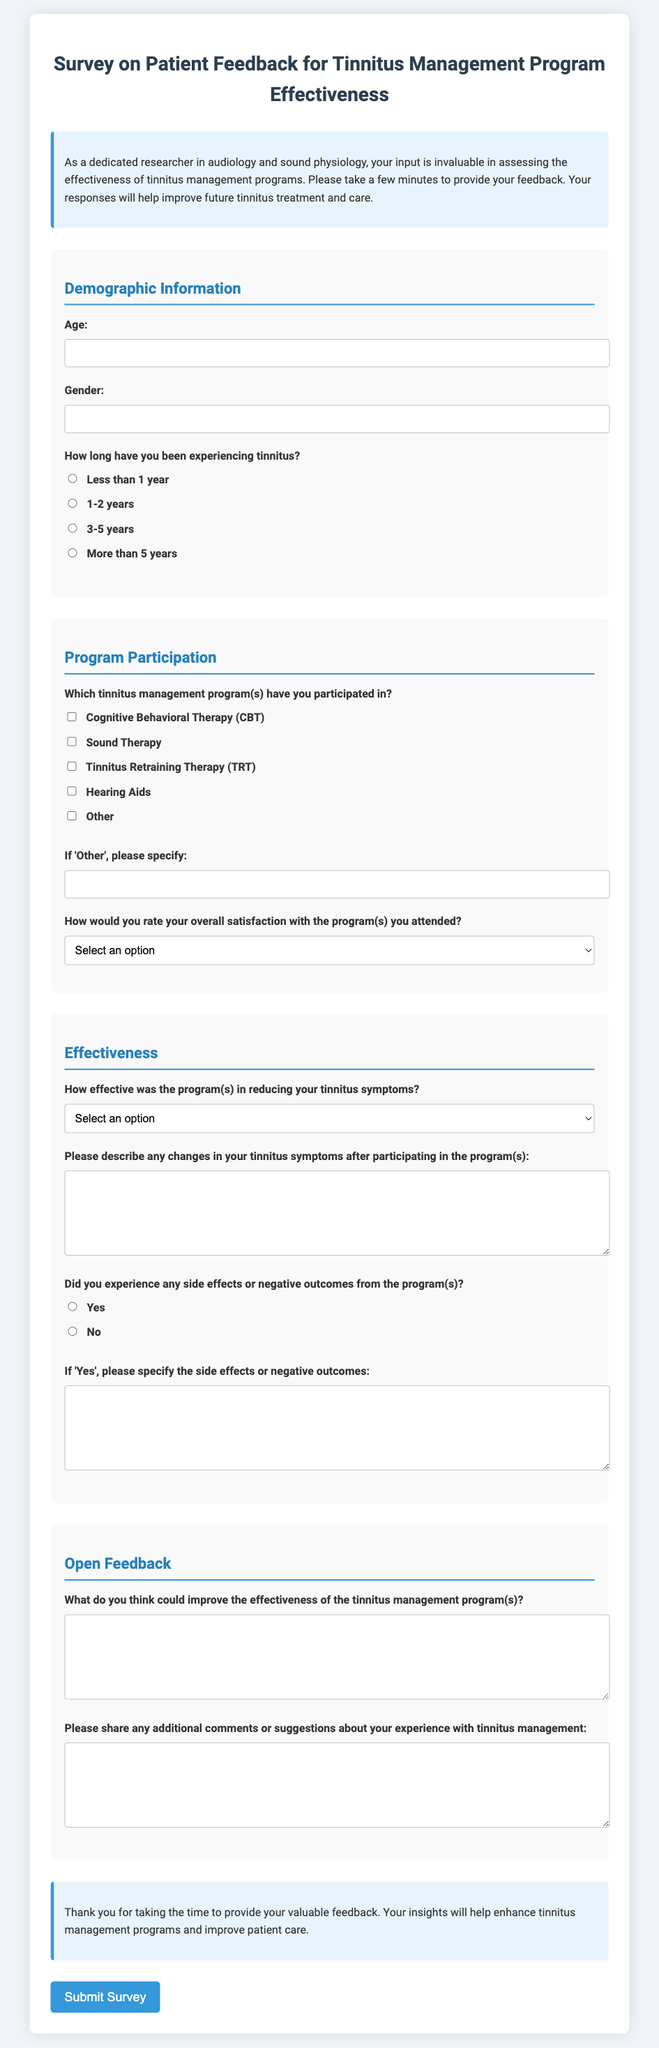What is the title of the document? The title of the document is found in the header section, stated prominently at the top of the form.
Answer: Survey on Patient Feedback for Tinnitus Management Program Effectiveness How many sections are in the survey form? The survey form is divided into four sections, each addressing different aspects of the feedback.
Answer: Four What age range must participants provide? The participants are required to provide their age in a short text format, indicated in the demographic information section.
Answer: Age Which therapy is included under program participation options? The document lists specific tinnitus management programs participants can choose from, including cognitive behavioral therapy.
Answer: Cognitive Behavioral Therapy (CBT) What is the satisfaction scale used in the survey? The satisfaction scale allows participants to select from five options, ranging from "Very Dissatisfied" to "Very Satisfied."
Answer: Five options What is the last question in the open feedback section? The last question allows participants to share additional comments or suggestions related to their experience with tinnitus management.
Answer: Please share any additional comments or suggestions about your experience with tinnitus management Did the survey inquire about side effects? Yes, the survey includes a question about any side effects or negative outcomes experienced from the programs.
Answer: Yes What type of feedback is the survey collecting? The survey is focused on collecting patient feedback specifically on the effectiveness of tinnitus management programs.
Answer: Patient feedback on effectiveness 